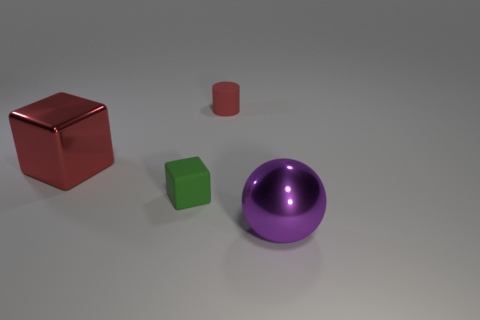Are there any other things that are the same shape as the purple shiny object?
Keep it short and to the point. No. There is a tiny green object that is to the left of the rubber thing behind the metallic cube; what is its material?
Provide a short and direct response. Rubber. There is a red object in front of the rubber cylinder; how big is it?
Make the answer very short. Large. What is the color of the object that is on the right side of the small green matte object and behind the small matte cube?
Offer a terse response. Red. There is a metallic thing left of the purple object; is it the same size as the big ball?
Provide a succinct answer. Yes. Are there any matte things that are on the right side of the large shiny object to the right of the red metal block?
Make the answer very short. No. What is the material of the large red object?
Give a very brief answer. Metal. There is a small green rubber thing; are there any purple objects in front of it?
Provide a succinct answer. Yes. What size is the red object that is the same shape as the green matte object?
Give a very brief answer. Large. Is the number of metal blocks that are behind the red shiny block the same as the number of objects on the left side of the small red cylinder?
Your answer should be very brief. No. 